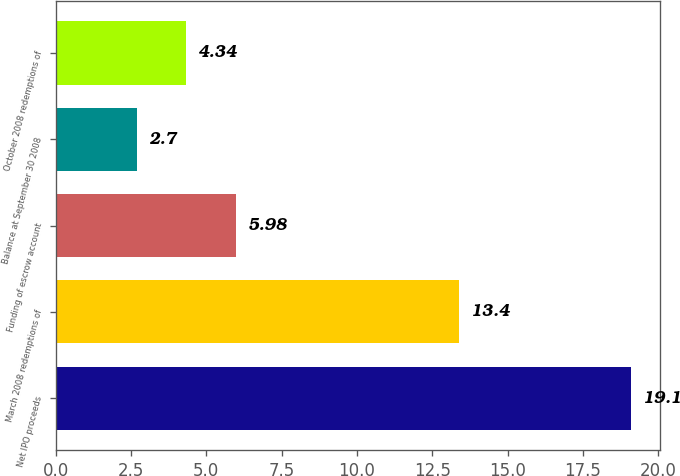Convert chart. <chart><loc_0><loc_0><loc_500><loc_500><bar_chart><fcel>Net IPO proceeds<fcel>March 2008 redemptions of<fcel>Funding of escrow account<fcel>Balance at September 30 2008<fcel>October 2008 redemptions of<nl><fcel>19.1<fcel>13.4<fcel>5.98<fcel>2.7<fcel>4.34<nl></chart> 